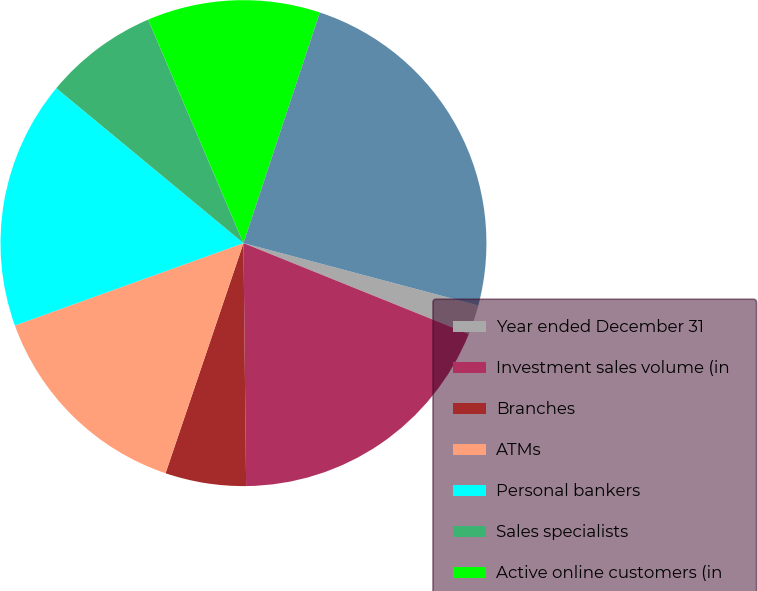Convert chart to OTSL. <chart><loc_0><loc_0><loc_500><loc_500><pie_chart><fcel>Year ended December 31<fcel>Investment sales volume (in<fcel>Branches<fcel>ATMs<fcel>Personal bankers<fcel>Sales specialists<fcel>Active online customers (in<fcel>Checking accounts (in<nl><fcel>1.97%<fcel>18.72%<fcel>5.37%<fcel>14.3%<fcel>16.51%<fcel>7.58%<fcel>11.5%<fcel>24.05%<nl></chart> 